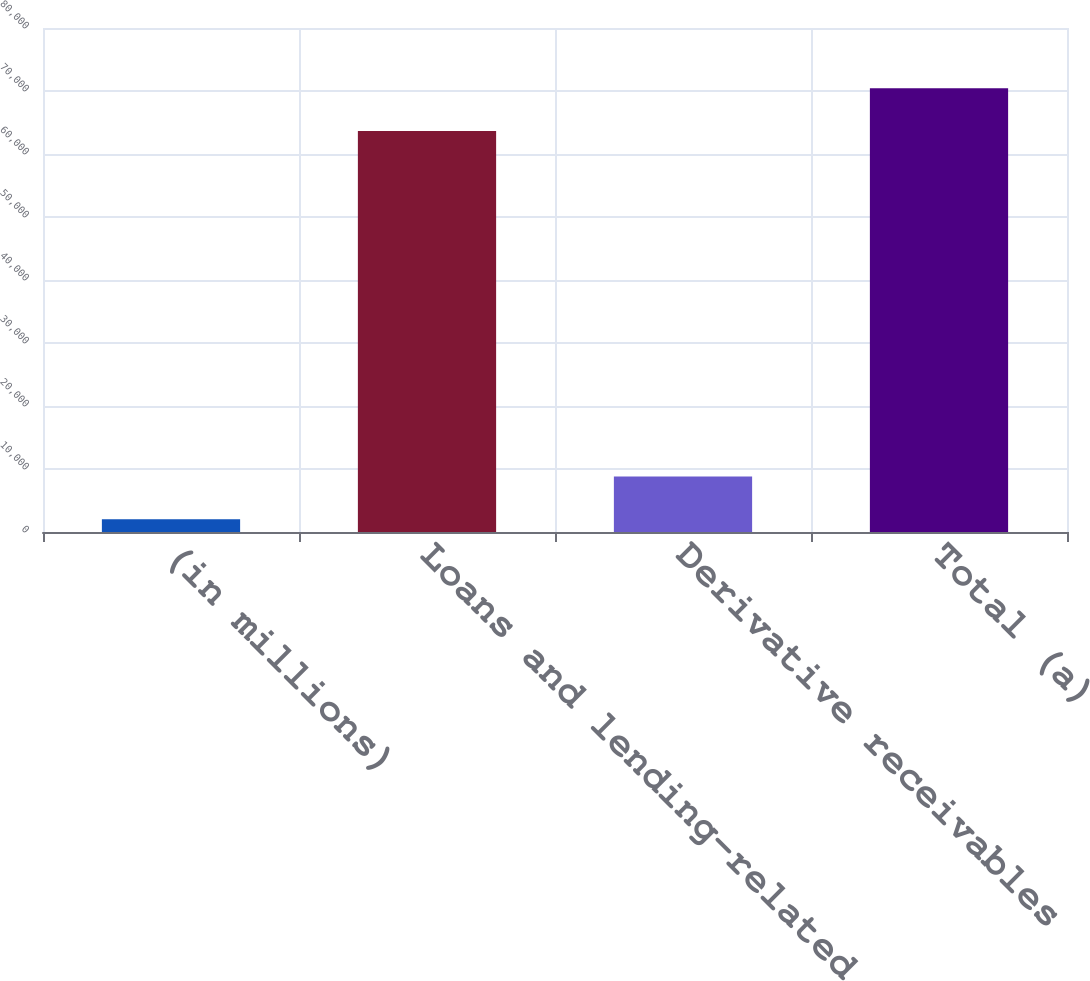Convert chart to OTSL. <chart><loc_0><loc_0><loc_500><loc_500><bar_chart><fcel>(in millions)<fcel>Loans and lending-related<fcel>Derivative receivables<fcel>Total (a)<nl><fcel>2007<fcel>63645<fcel>8817<fcel>70455<nl></chart> 